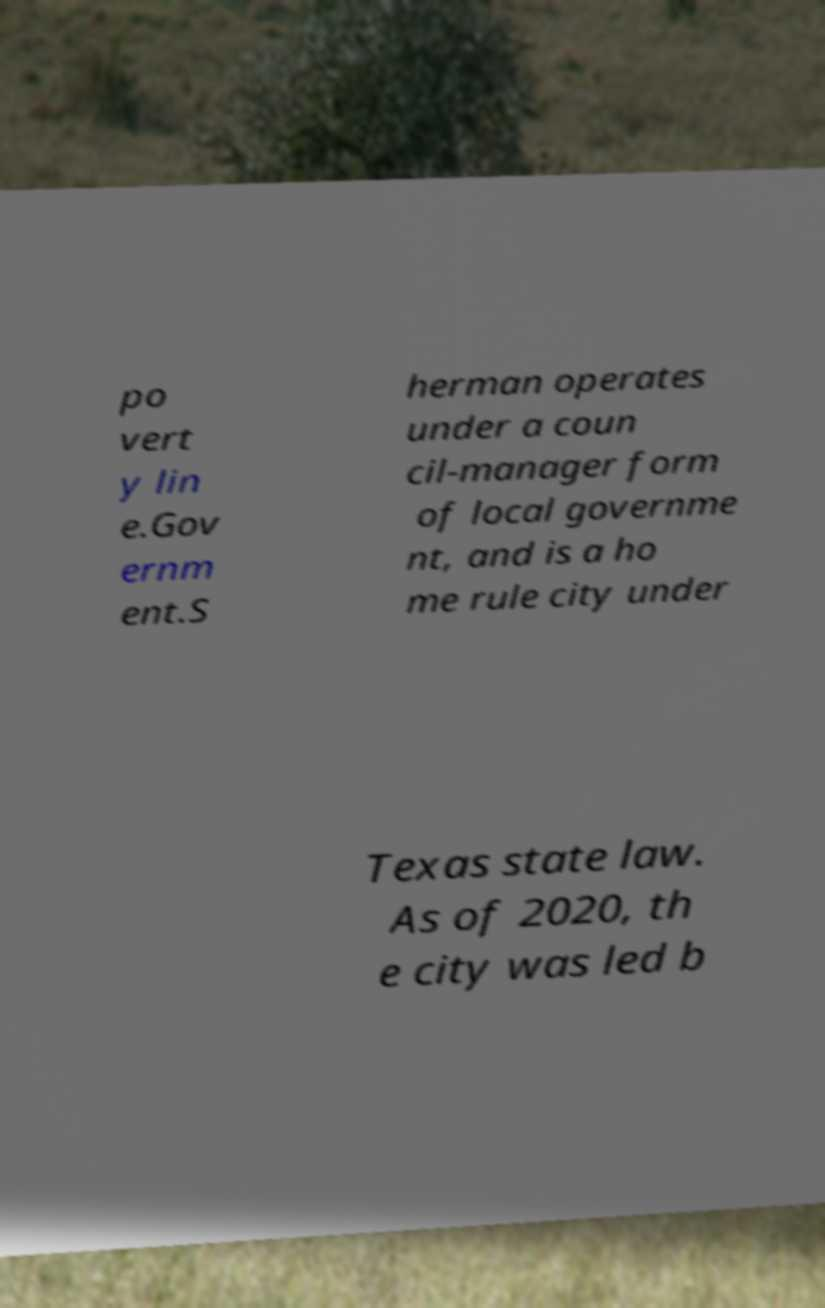Please identify and transcribe the text found in this image. po vert y lin e.Gov ernm ent.S herman operates under a coun cil-manager form of local governme nt, and is a ho me rule city under Texas state law. As of 2020, th e city was led b 